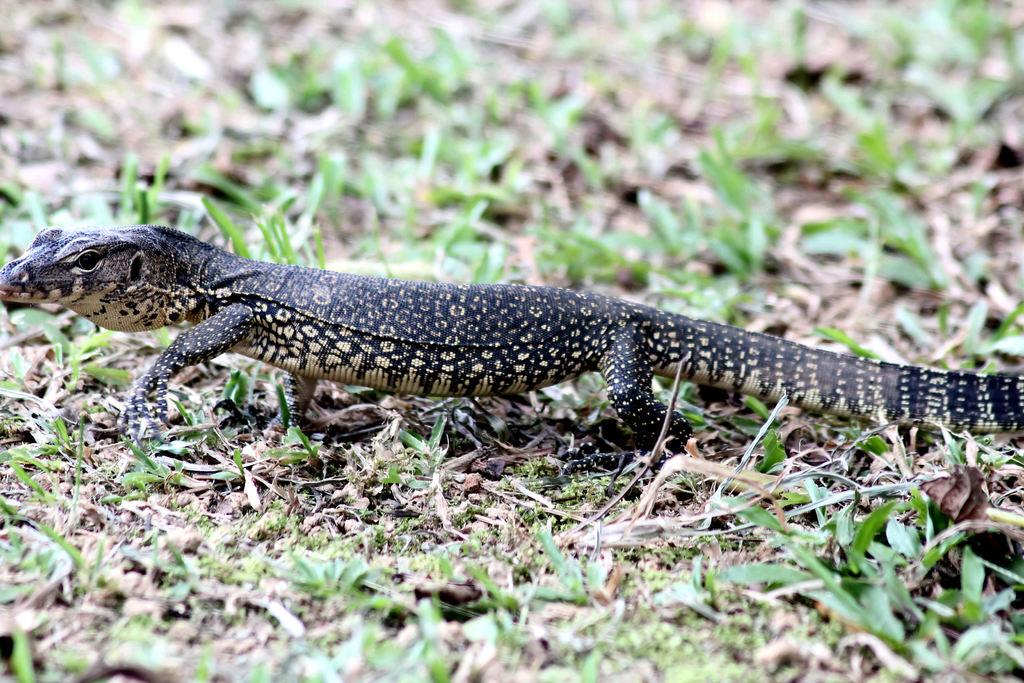What type of animal is in the image? There is an alligator lizard in the image. Where is the alligator lizard located? The alligator lizard is on the grass. Can you tell me how many donkeys are present in the image? There are no donkeys present in the image; it features an alligator lizard on the grass. What type of hill can be seen in the background of the image? There is no hill visible in the image; it only shows an alligator lizard on the grass. 